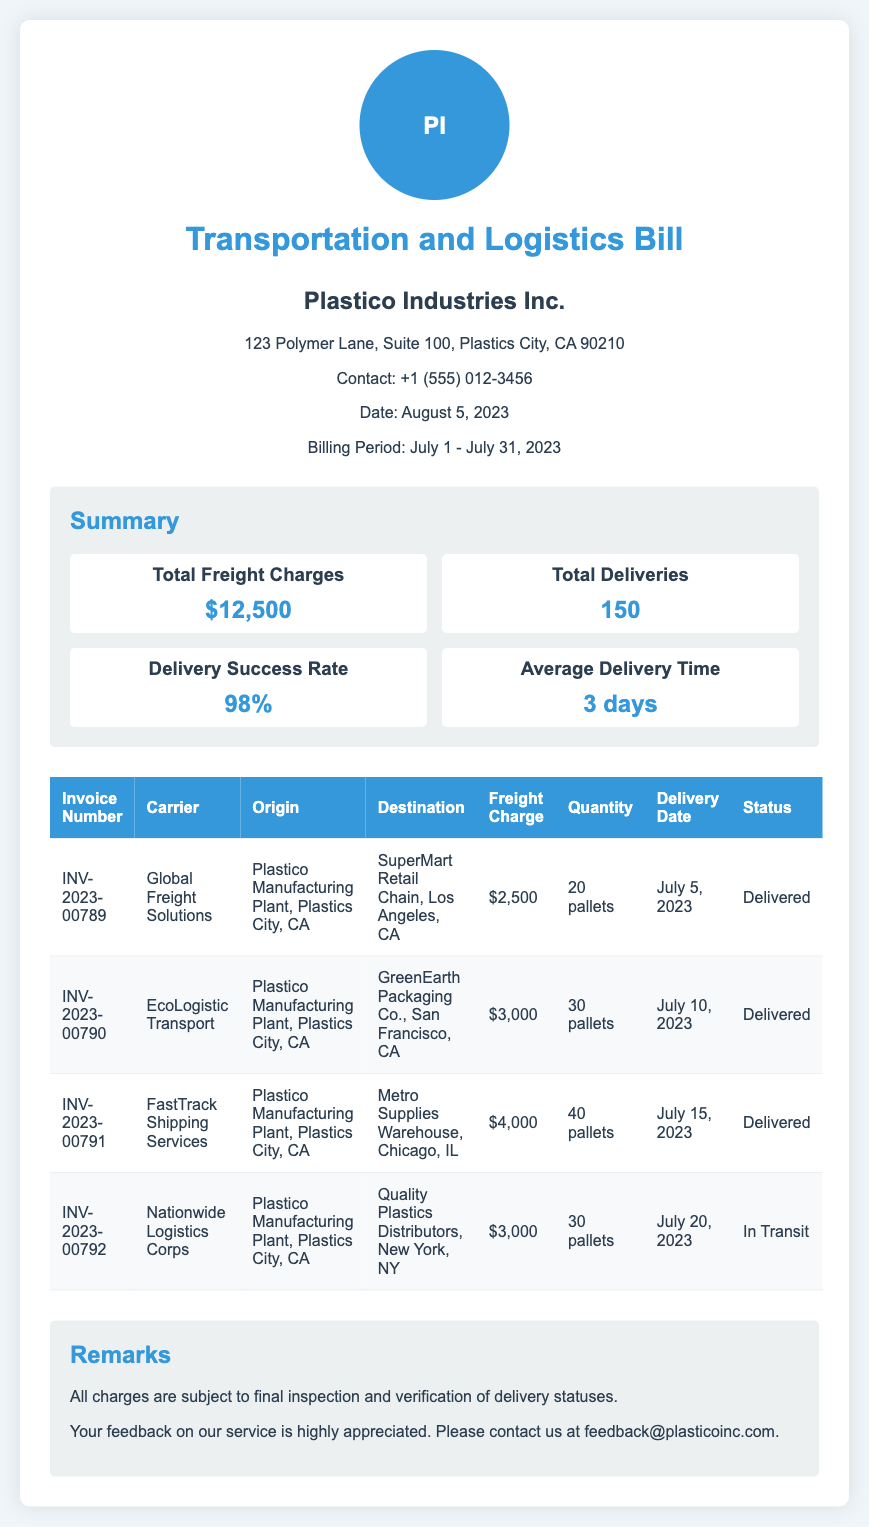what is the total freight charge? The total freight charge is listed in the summary section of the document as $12,500.
Answer: $12,500 how many total deliveries were made? The total number of deliveries is specified in the summary section of the document as 150.
Answer: 150 what is the average delivery time? The average delivery time is presented in the summary section of the document as 3 days.
Answer: 3 days which carrier handled the delivery to San Francisco? The delivery to GreenEarth Packaging Co., San Francisco, is handled by EcoLogistic Transport, as shown in the table.
Answer: EcoLogistic Transport what was the delivery date for the shipment to New York? The delivery date for the shipment to Quality Plastics Distributors, New York, is listed as July 20, 2023, in the table.
Answer: July 20, 2023 what is the status of the latest delivery? The status of the latest delivery, which is to Quality Plastics Distributors, is noted as "In Transit" in the table.
Answer: In Transit how many pallets were delivered to Los Angeles? The number of pallets delivered to SuperMart Retail Chain in Los Angeles is stated as 20 pallets in the table.
Answer: 20 pallets what is the delivery success rate? The delivery success rate is given in the summary section of the document as 98%.
Answer: 98% what is the invoice number for the shipment to Chicago? The invoice number for the shipment to Metro Supplies Warehouse, Chicago, is provided as INV-2023-00791 in the table.
Answer: INV-2023-00791 